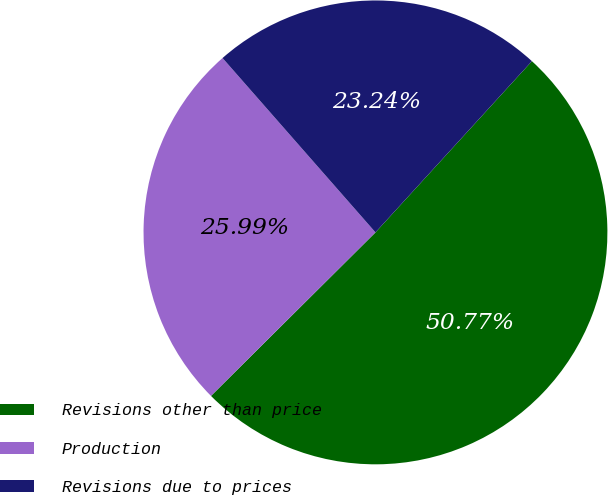Convert chart. <chart><loc_0><loc_0><loc_500><loc_500><pie_chart><fcel>Revisions other than price<fcel>Production<fcel>Revisions due to prices<nl><fcel>50.76%<fcel>25.99%<fcel>23.24%<nl></chart> 